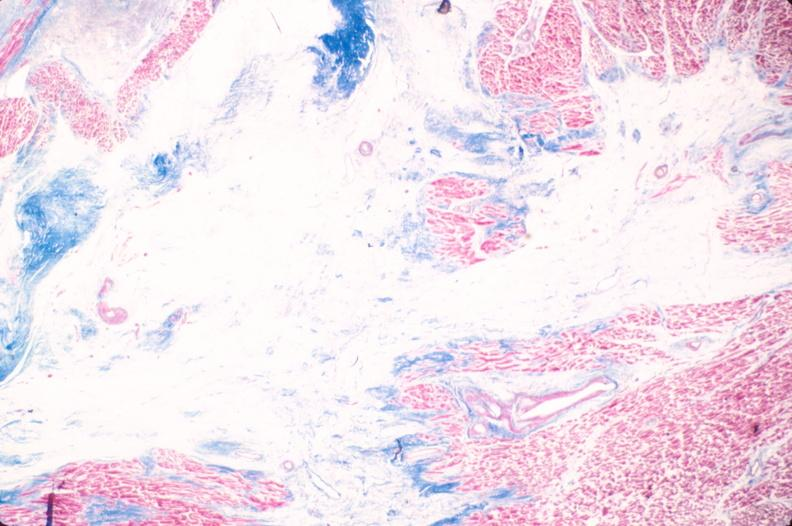where is this in?
Answer the question using a single word or phrase. In heart 